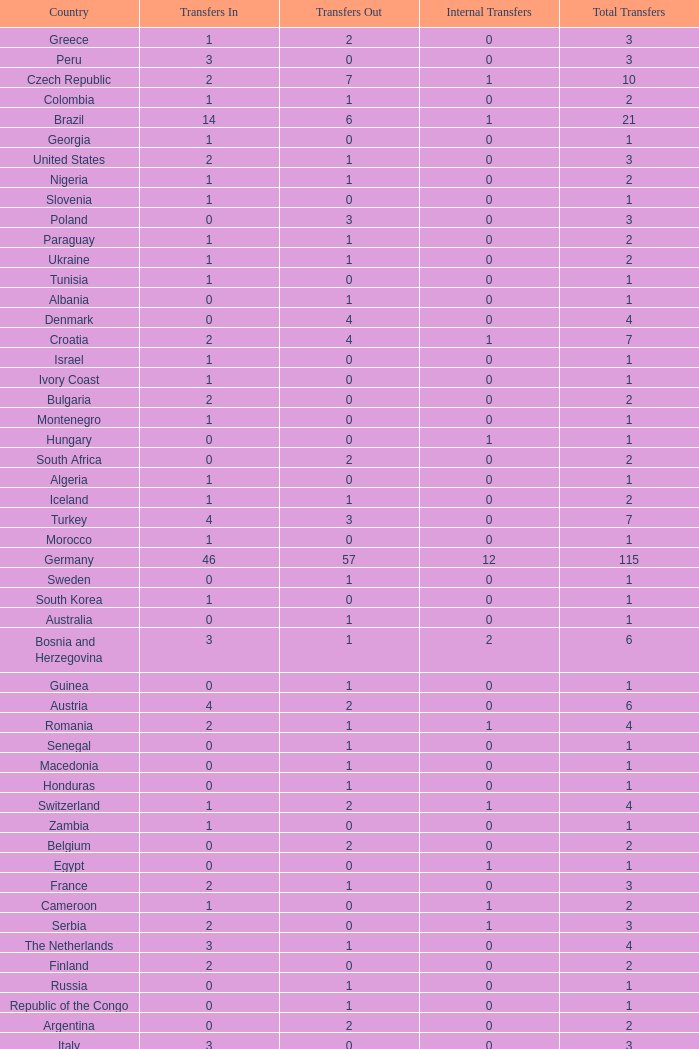What are the transfers in for Hungary? 0.0. 